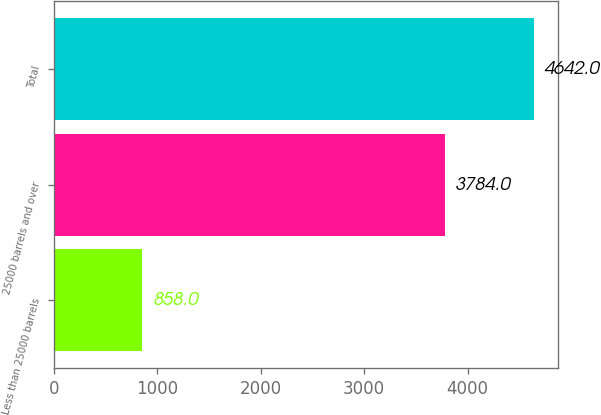Convert chart. <chart><loc_0><loc_0><loc_500><loc_500><bar_chart><fcel>Less than 25000 barrels<fcel>25000 barrels and over<fcel>Total<nl><fcel>858<fcel>3784<fcel>4642<nl></chart> 